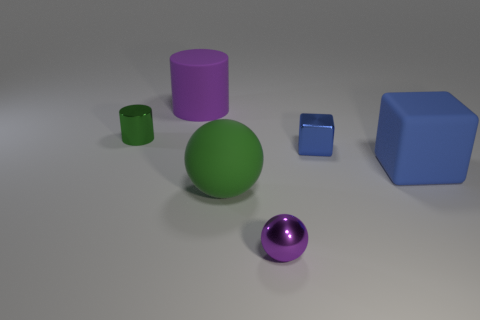How many other objects are there of the same material as the large sphere?
Your response must be concise. 2. Do the large object that is behind the blue metallic block and the block that is in front of the small block have the same material?
Give a very brief answer. Yes. There is a large green object that is the same material as the purple cylinder; what is its shape?
Provide a succinct answer. Sphere. How many large brown rubber cubes are there?
Your answer should be compact. 0. What is the shape of the tiny shiny thing that is to the right of the tiny green object and behind the large rubber ball?
Provide a short and direct response. Cube. What shape is the green thing that is to the right of the purple object that is on the left side of the tiny purple object to the right of the small green thing?
Make the answer very short. Sphere. There is a big object that is behind the big green ball and in front of the purple rubber object; what is its material?
Ensure brevity in your answer.  Rubber. How many blue things are the same size as the metal ball?
Give a very brief answer. 1. How many rubber things are large purple things or big balls?
Offer a very short reply. 2. What material is the tiny green thing?
Offer a terse response. Metal. 